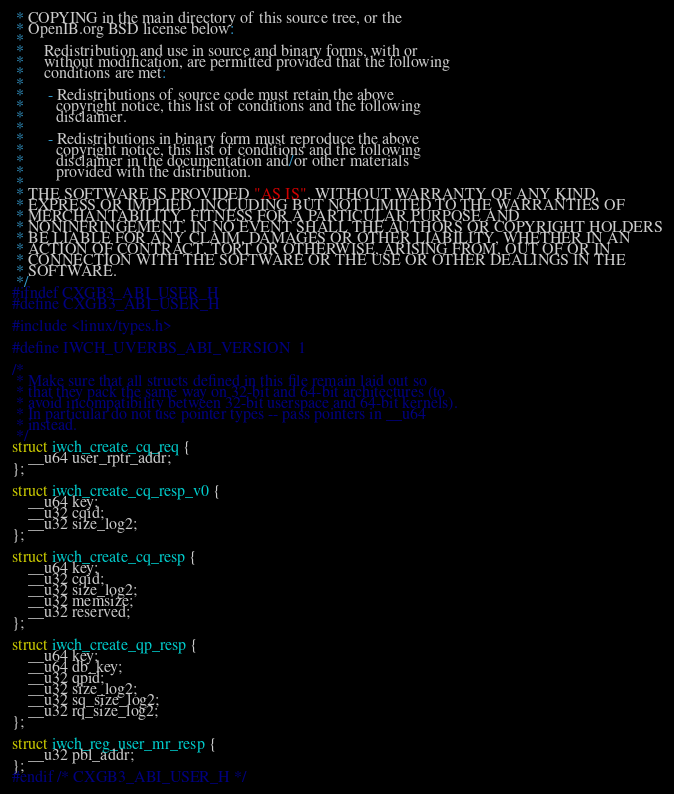Convert code to text. <code><loc_0><loc_0><loc_500><loc_500><_C_> * COPYING in the main directory of this source tree, or the
 * OpenIB.org BSD license below:
 *
 *     Redistribution and use in source and binary forms, with or
 *     without modification, are permitted provided that the following
 *     conditions are met:
 *
 *      - Redistributions of source code must retain the above
 *        copyright notice, this list of conditions and the following
 *        disclaimer.
 *
 *      - Redistributions in binary form must reproduce the above
 *        copyright notice, this list of conditions and the following
 *        disclaimer in the documentation and/or other materials
 *        provided with the distribution.
 *
 * THE SOFTWARE IS PROVIDED "AS IS", WITHOUT WARRANTY OF ANY KIND,
 * EXPRESS OR IMPLIED, INCLUDING BUT NOT LIMITED TO THE WARRANTIES OF
 * MERCHANTABILITY, FITNESS FOR A PARTICULAR PURPOSE AND
 * NONINFRINGEMENT. IN NO EVENT SHALL THE AUTHORS OR COPYRIGHT HOLDERS
 * BE LIABLE FOR ANY CLAIM, DAMAGES OR OTHER LIABILITY, WHETHER IN AN
 * ACTION OF CONTRACT, TORT OR OTHERWISE, ARISING FROM, OUT OF OR IN
 * CONNECTION WITH THE SOFTWARE OR THE USE OR OTHER DEALINGS IN THE
 * SOFTWARE.
 */
#ifndef CXGB3_ABI_USER_H
#define CXGB3_ABI_USER_H

#include <linux/types.h>

#define IWCH_UVERBS_ABI_VERSION	1

/*
 * Make sure that all structs defined in this file remain laid out so
 * that they pack the same way on 32-bit and 64-bit architectures (to
 * avoid incompatibility between 32-bit userspace and 64-bit kernels).
 * In particular do not use pointer types -- pass pointers in __u64
 * instead.
 */
struct iwch_create_cq_req {
	__u64 user_rptr_addr;
};

struct iwch_create_cq_resp_v0 {
	__u64 key;
	__u32 cqid;
	__u32 size_log2;
};

struct iwch_create_cq_resp {
	__u64 key;
	__u32 cqid;
	__u32 size_log2;
	__u32 memsize;
	__u32 reserved;
};

struct iwch_create_qp_resp {
	__u64 key;
	__u64 db_key;
	__u32 qpid;
	__u32 size_log2;
	__u32 sq_size_log2;
	__u32 rq_size_log2;
};

struct iwch_reg_user_mr_resp {
	__u32 pbl_addr;
};
#endif /* CXGB3_ABI_USER_H */
</code> 